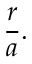Convert formula to latex. <formula><loc_0><loc_0><loc_500><loc_500>{ \frac { r } { a } } .</formula> 